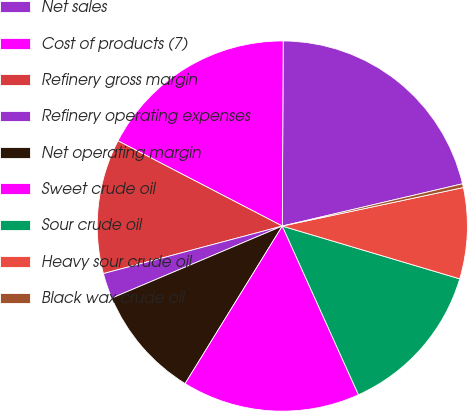<chart> <loc_0><loc_0><loc_500><loc_500><pie_chart><fcel>Net sales<fcel>Cost of products (7)<fcel>Refinery gross margin<fcel>Refinery operating expenses<fcel>Net operating margin<fcel>Sweet crude oil<fcel>Sour crude oil<fcel>Heavy sour crude oil<fcel>Black wax crude oil<nl><fcel>21.26%<fcel>17.46%<fcel>11.75%<fcel>2.23%<fcel>9.84%<fcel>15.55%<fcel>13.65%<fcel>7.94%<fcel>0.33%<nl></chart> 